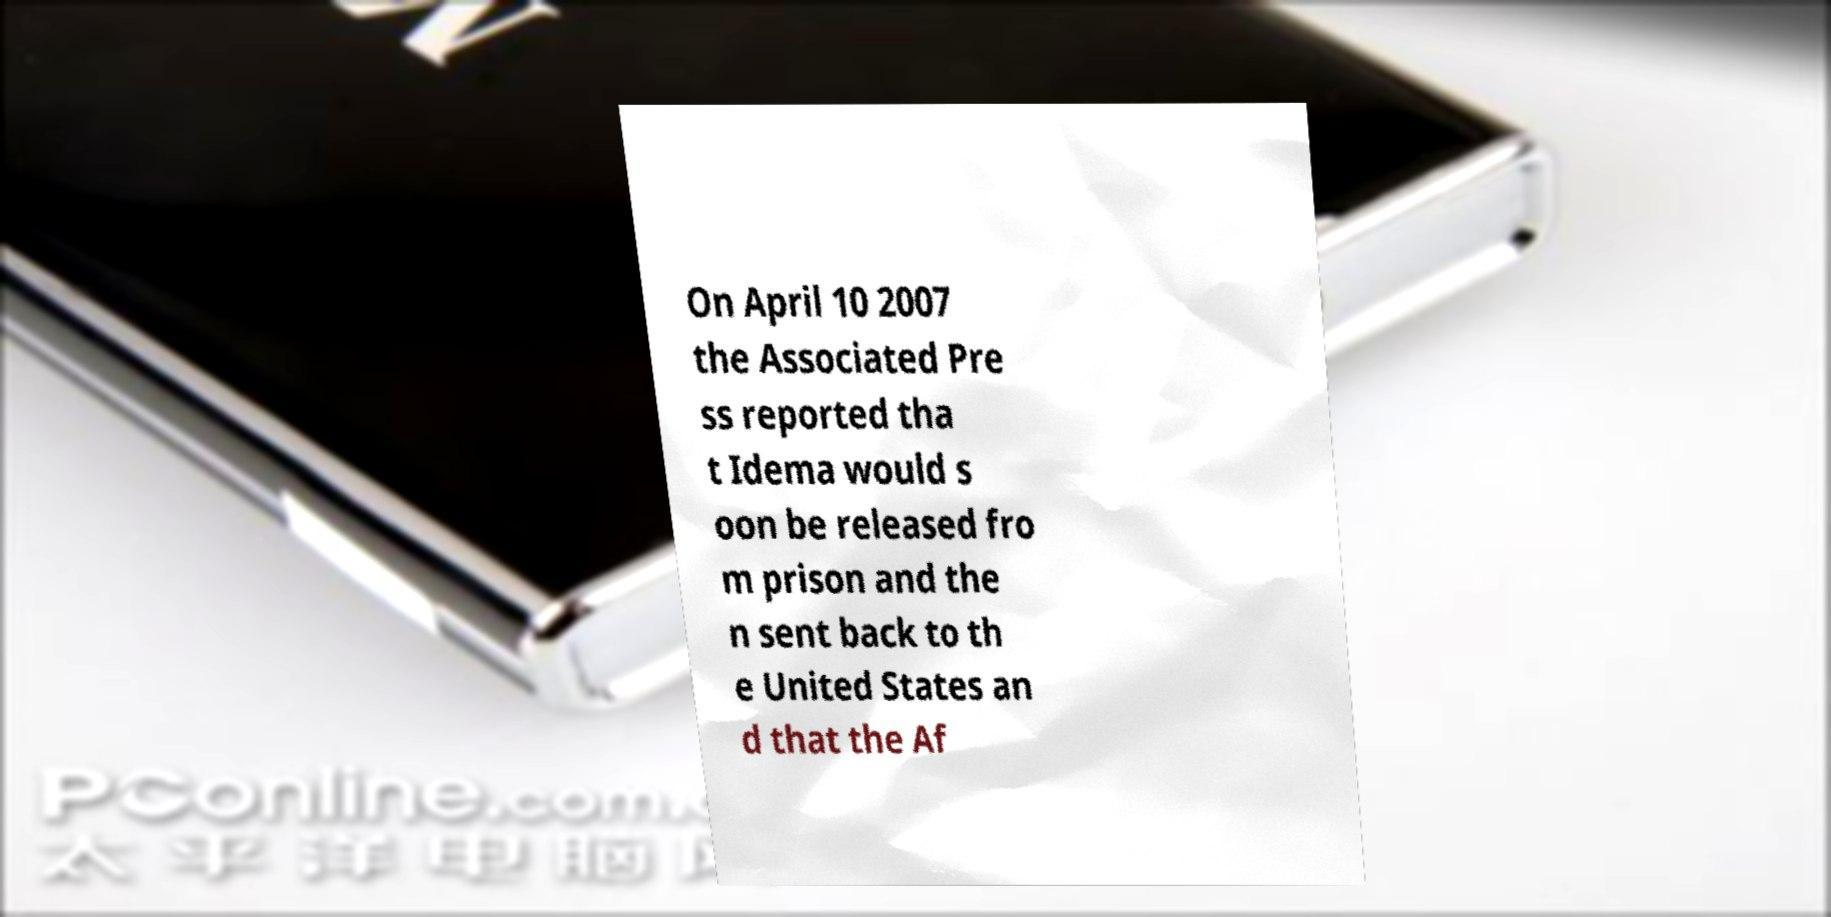Could you assist in decoding the text presented in this image and type it out clearly? On April 10 2007 the Associated Pre ss reported tha t Idema would s oon be released fro m prison and the n sent back to th e United States an d that the Af 